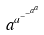<formula> <loc_0><loc_0><loc_500><loc_500>a ^ { a ^ { - ^ { - ^ { a ^ { a } } } } }</formula> 